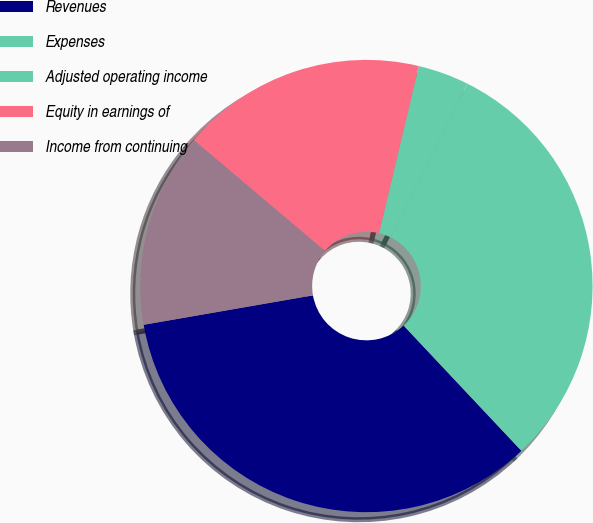<chart> <loc_0><loc_0><loc_500><loc_500><pie_chart><fcel>Revenues<fcel>Expenses<fcel>Adjusted operating income<fcel>Equity in earnings of<fcel>Income from continuing<nl><fcel>34.27%<fcel>30.63%<fcel>3.64%<fcel>17.55%<fcel>13.91%<nl></chart> 